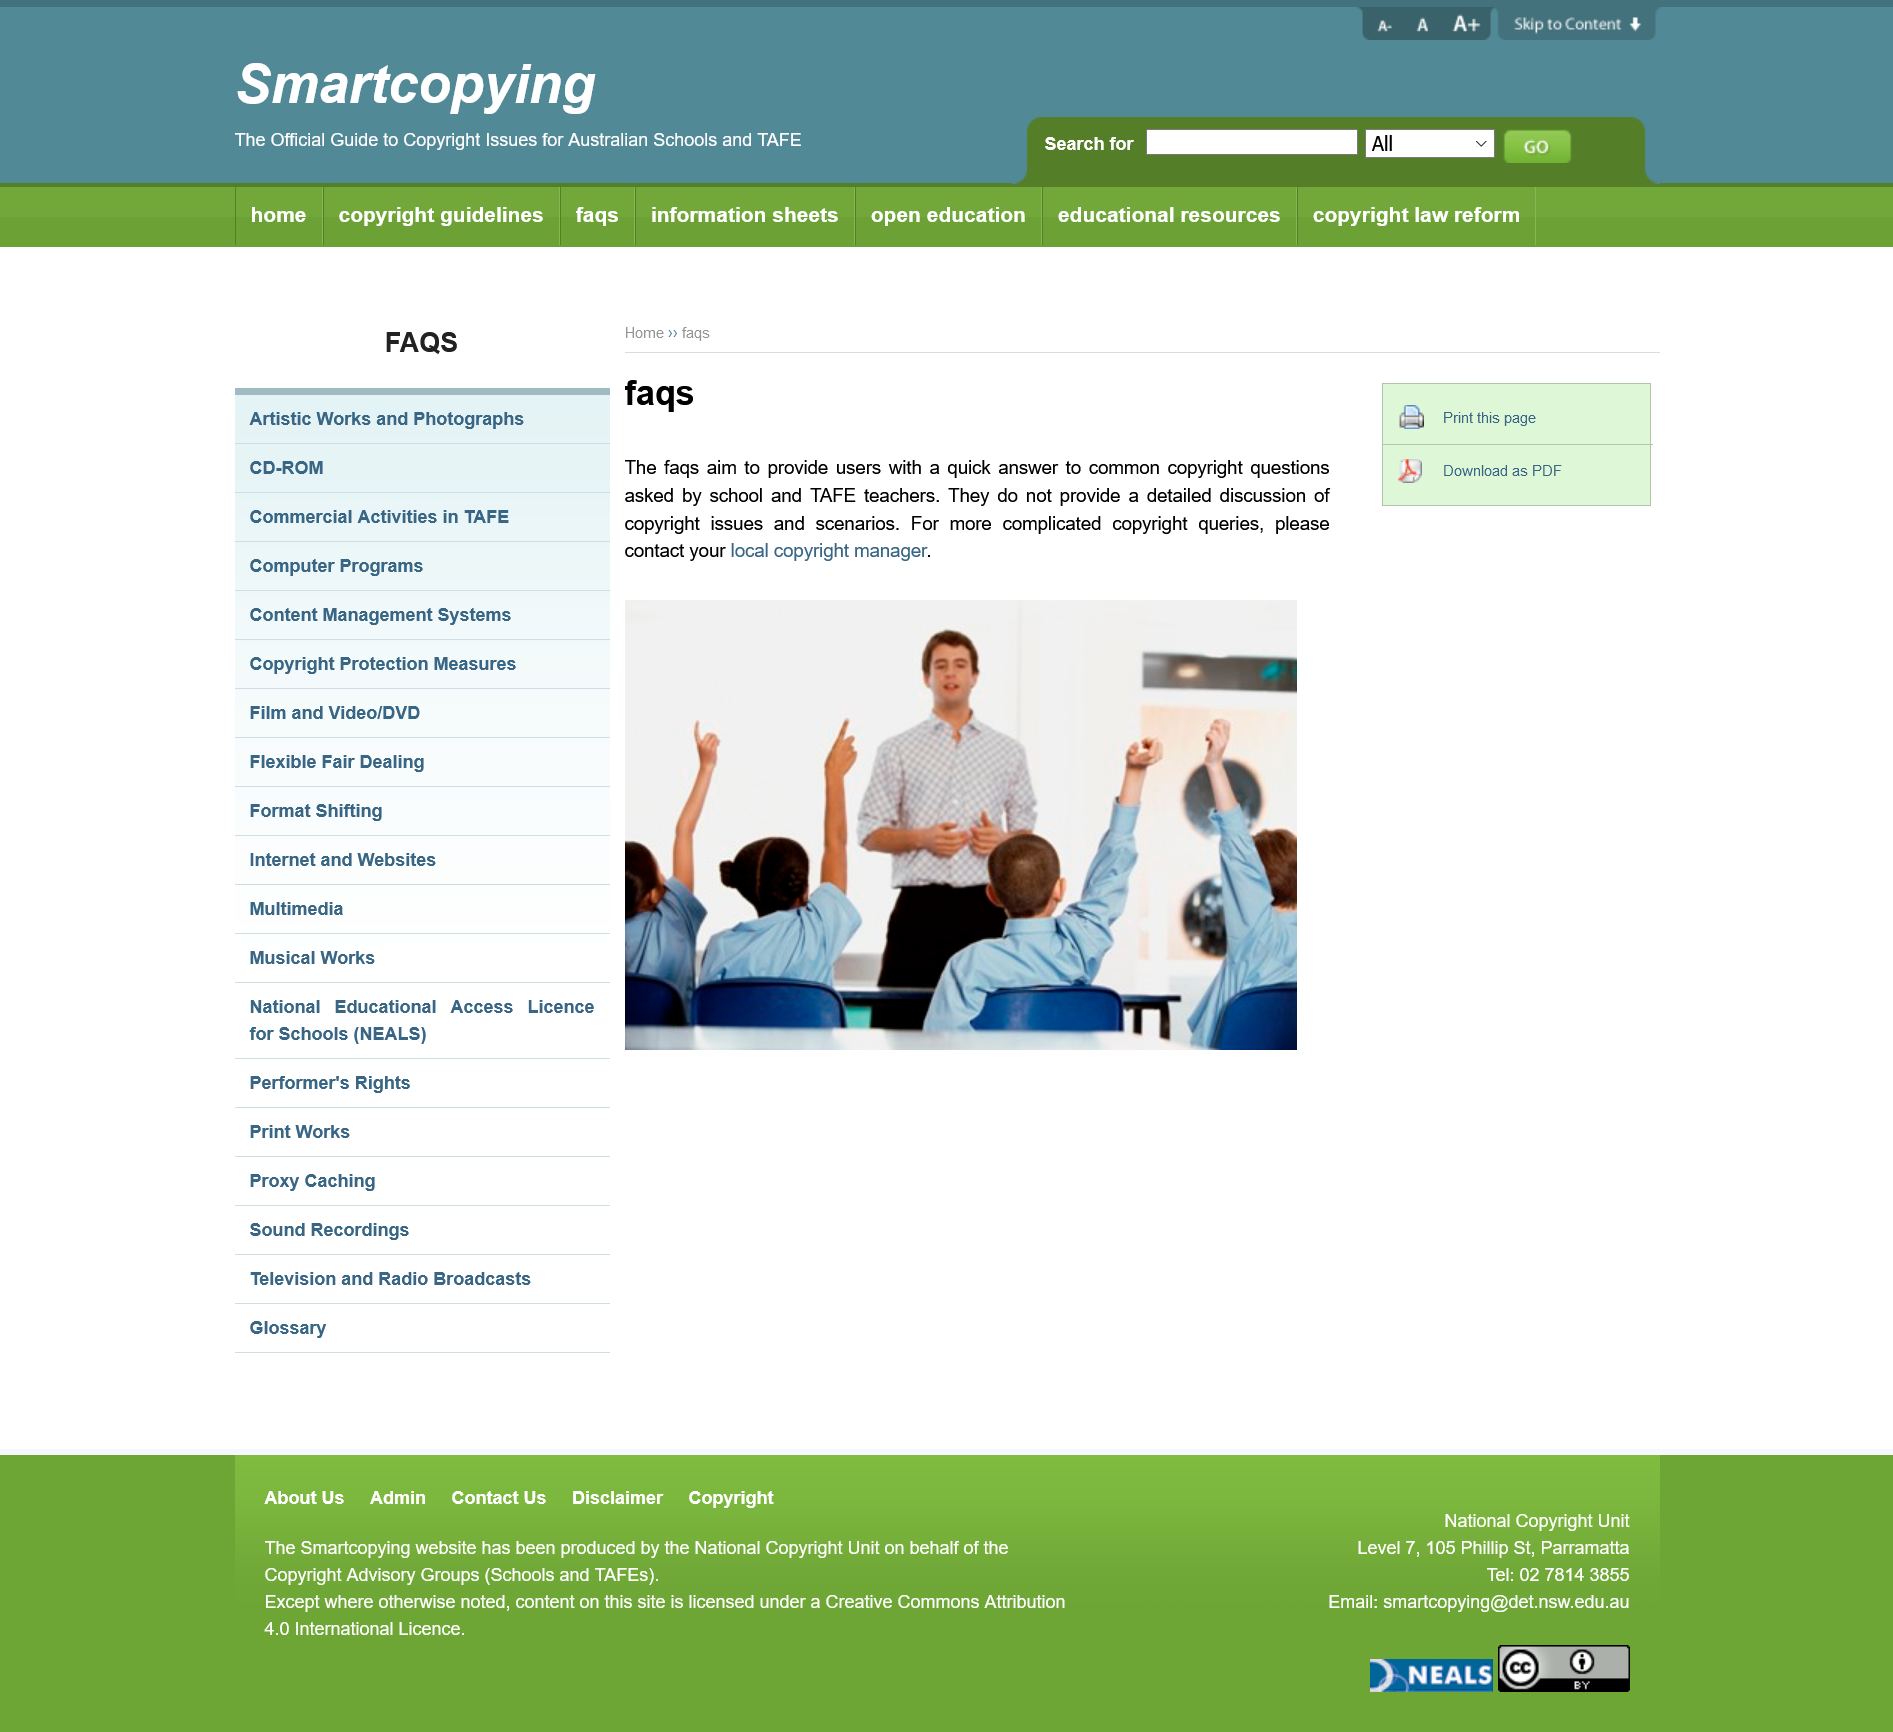Give some essential details in this illustration. The FAQs section aims to provide answers to common copyright questions. The title of this page is "FAQS". In cases of complex copyright queries, it is recommended that you contact your local copyright manager. 